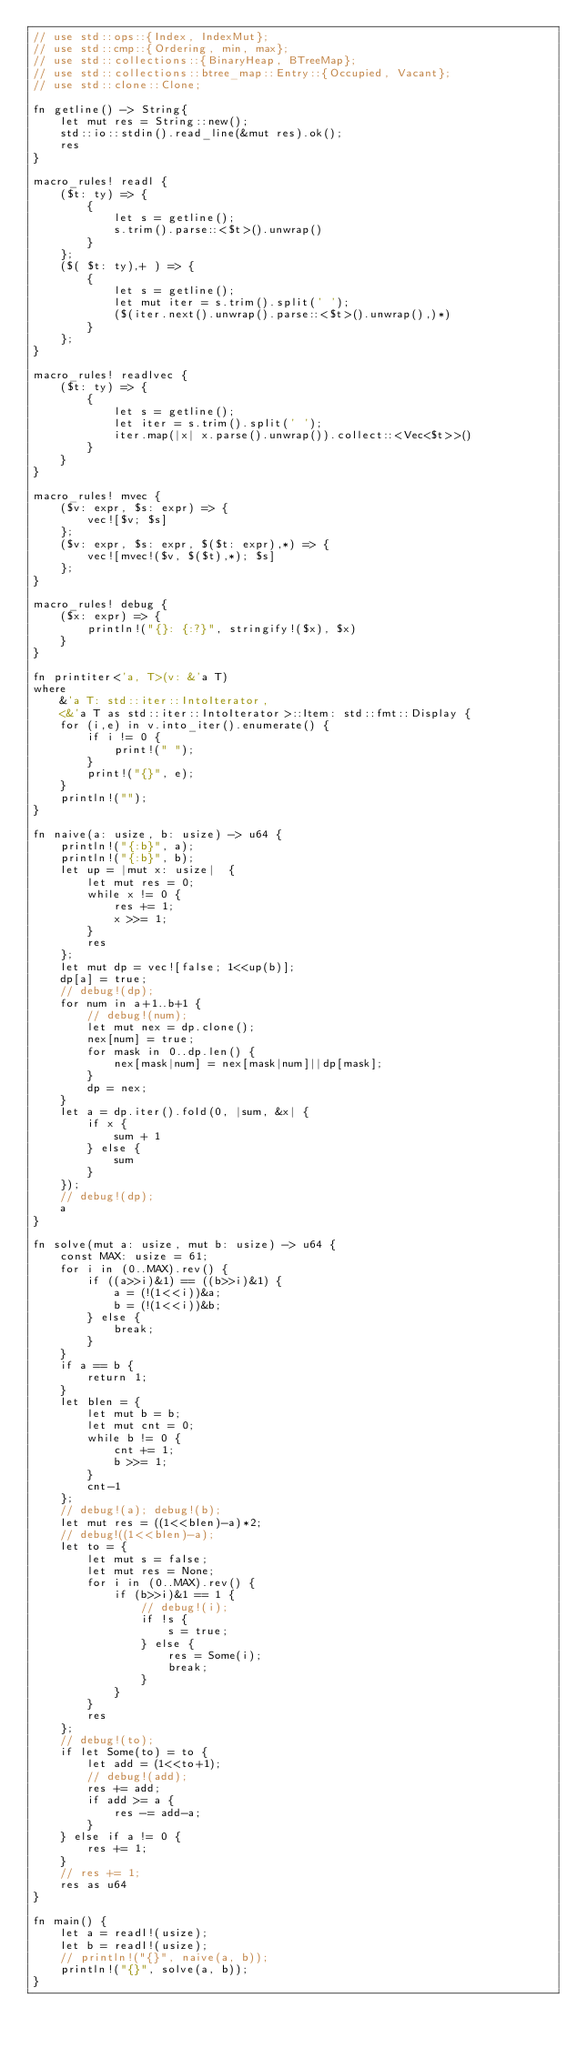Convert code to text. <code><loc_0><loc_0><loc_500><loc_500><_Rust_>// use std::ops::{Index, IndexMut};
// use std::cmp::{Ordering, min, max};
// use std::collections::{BinaryHeap, BTreeMap};
// use std::collections::btree_map::Entry::{Occupied, Vacant};
// use std::clone::Clone;

fn getline() -> String{
    let mut res = String::new();
    std::io::stdin().read_line(&mut res).ok();
    res
}

macro_rules! readl {
    ($t: ty) => {
        {
            let s = getline();
            s.trim().parse::<$t>().unwrap()
        }
    };
    ($( $t: ty),+ ) => {
        {
            let s = getline();
            let mut iter = s.trim().split(' ');
            ($(iter.next().unwrap().parse::<$t>().unwrap(),)*) 
        }
    };
}

macro_rules! readlvec {
    ($t: ty) => {
        {
            let s = getline();
            let iter = s.trim().split(' ');
            iter.map(|x| x.parse().unwrap()).collect::<Vec<$t>>()
        }
    }
}

macro_rules! mvec {
    ($v: expr, $s: expr) => {
        vec![$v; $s]
    };
    ($v: expr, $s: expr, $($t: expr),*) => {
        vec![mvec!($v, $($t),*); $s]
    };
}

macro_rules! debug {
    ($x: expr) => {
        println!("{}: {:?}", stringify!($x), $x)
    }
}

fn printiter<'a, T>(v: &'a T)
where
    &'a T: std::iter::IntoIterator, 
    <&'a T as std::iter::IntoIterator>::Item: std::fmt::Display {
    for (i,e) in v.into_iter().enumerate() {
        if i != 0 {
            print!(" ");
        }
        print!("{}", e);
    }
    println!("");
}

fn naive(a: usize, b: usize) -> u64 {
    println!("{:b}", a);
    println!("{:b}", b);
    let up = |mut x: usize|  {
        let mut res = 0;
        while x != 0 {
            res += 1;
            x >>= 1;
        }
        res
    };
    let mut dp = vec![false; 1<<up(b)];
    dp[a] = true;
    // debug!(dp);
    for num in a+1..b+1 {
        // debug!(num);
        let mut nex = dp.clone();
        nex[num] = true;
        for mask in 0..dp.len() {
            nex[mask|num] = nex[mask|num]||dp[mask];
        }
        dp = nex;
    }
    let a = dp.iter().fold(0, |sum, &x| {
        if x {
            sum + 1
        } else {
            sum
        }
    });
    // debug!(dp);
    a
}

fn solve(mut a: usize, mut b: usize) -> u64 {
    const MAX: usize = 61;
    for i in (0..MAX).rev() {
        if ((a>>i)&1) == ((b>>i)&1) {
            a = (!(1<<i))&a;
            b = (!(1<<i))&b;
        } else {
            break;
        }
    }
    if a == b {
        return 1;
    }
    let blen = {
        let mut b = b;
        let mut cnt = 0;
        while b != 0 {
            cnt += 1;
            b >>= 1;
        }
        cnt-1
    };
    // debug!(a); debug!(b);
    let mut res = ((1<<blen)-a)*2;
    // debug!((1<<blen)-a);
    let to = {
        let mut s = false;
        let mut res = None;
        for i in (0..MAX).rev() {
            if (b>>i)&1 == 1 {
                // debug!(i);
                if !s {
                    s = true;
                } else {
                    res = Some(i);
                    break;
                }
            }
        }
        res
    };
    // debug!(to);
    if let Some(to) = to {
        let add = (1<<to+1);
        // debug!(add);
        res += add;
        if add >= a {
            res -= add-a;
        }
    } else if a != 0 {
        res += 1;
    }
    // res += 1;
    res as u64
}

fn main() {
    let a = readl!(usize);
    let b = readl!(usize);
    // println!("{}", naive(a, b));
    println!("{}", solve(a, b));
}

</code> 